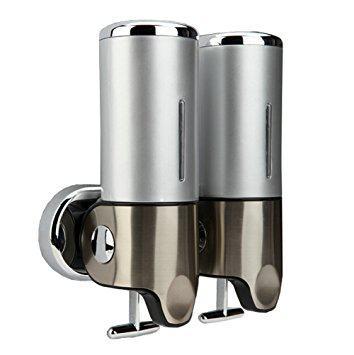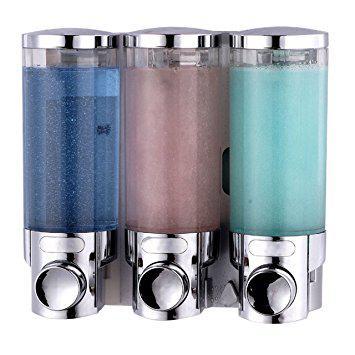The first image is the image on the left, the second image is the image on the right. Given the left and right images, does the statement "A three-in-one joined dispenser holds substances of three different colors that show through the transparent top portions." hold true? Answer yes or no. Yes. The first image is the image on the left, the second image is the image on the right. Evaluate the accuracy of this statement regarding the images: "The right hand image shows three dispensers that each have a different color of liquid inside of them.". Is it true? Answer yes or no. Yes. 